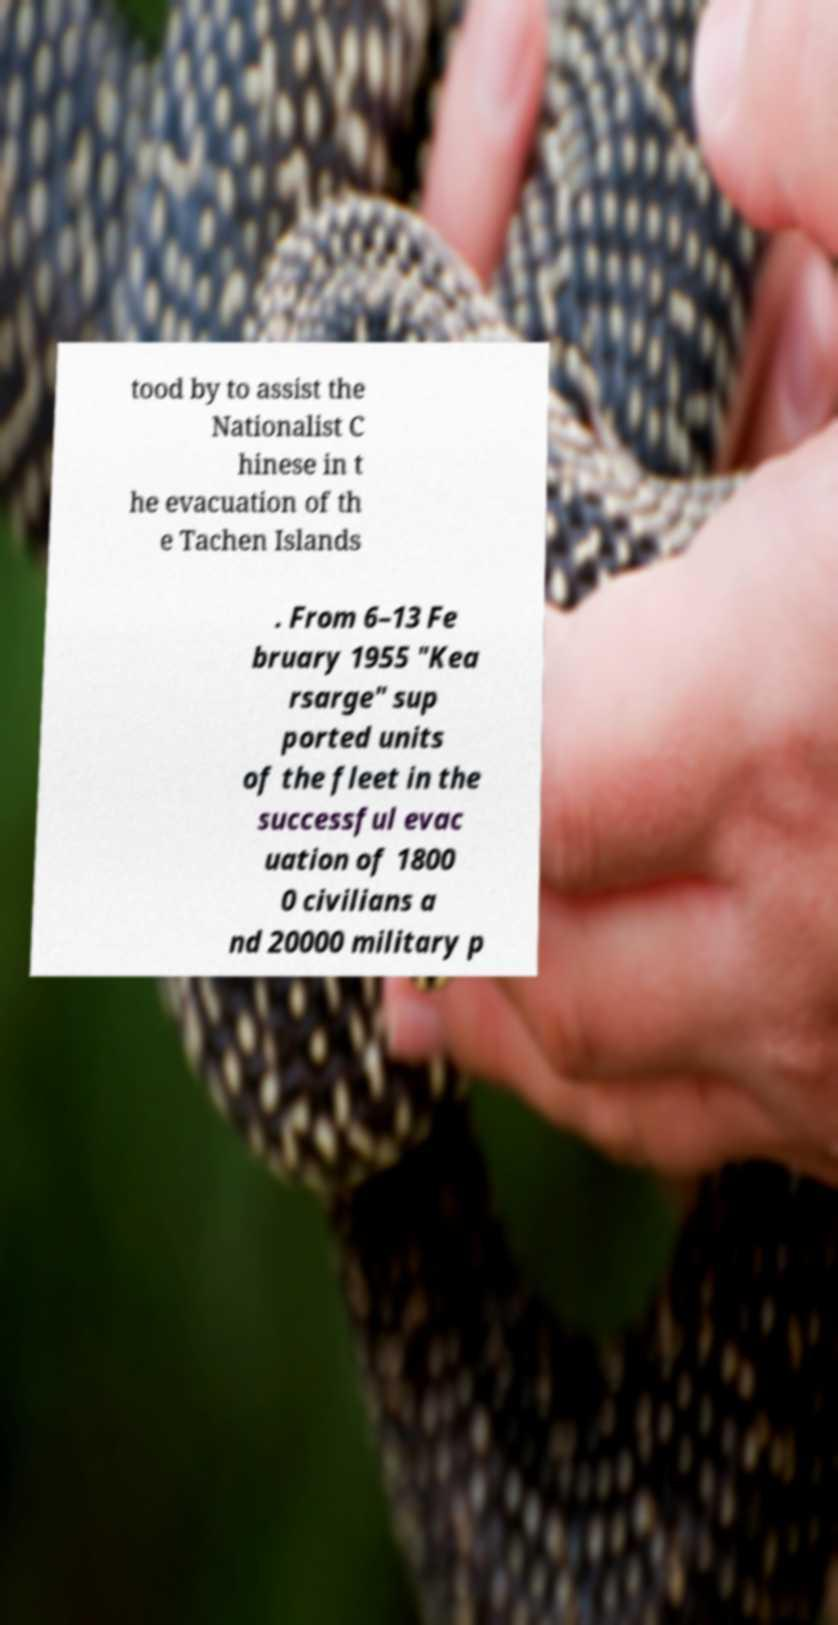Could you extract and type out the text from this image? tood by to assist the Nationalist C hinese in t he evacuation of th e Tachen Islands . From 6–13 Fe bruary 1955 "Kea rsarge" sup ported units of the fleet in the successful evac uation of 1800 0 civilians a nd 20000 military p 